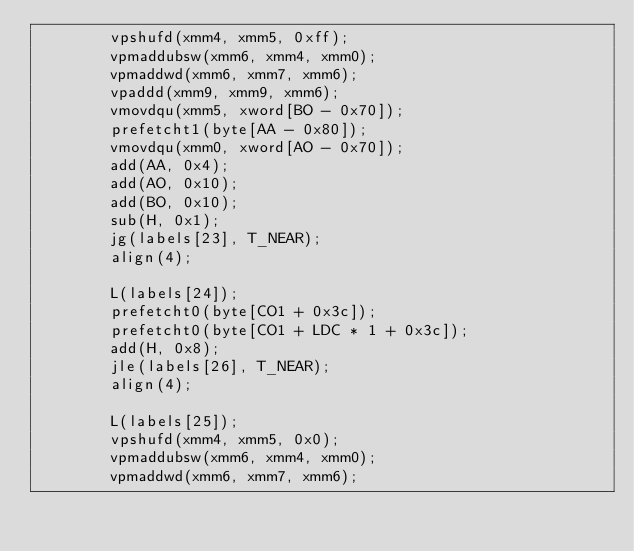Convert code to text. <code><loc_0><loc_0><loc_500><loc_500><_C++_>        vpshufd(xmm4, xmm5, 0xff);
        vpmaddubsw(xmm6, xmm4, xmm0);
        vpmaddwd(xmm6, xmm7, xmm6);
        vpaddd(xmm9, xmm9, xmm6);
        vmovdqu(xmm5, xword[BO - 0x70]);
        prefetcht1(byte[AA - 0x80]);
        vmovdqu(xmm0, xword[AO - 0x70]);
        add(AA, 0x4);
        add(AO, 0x10);
        add(BO, 0x10);
        sub(H, 0x1);
        jg(labels[23], T_NEAR);
        align(4);

        L(labels[24]);
        prefetcht0(byte[CO1 + 0x3c]);
        prefetcht0(byte[CO1 + LDC * 1 + 0x3c]);
        add(H, 0x8);
        jle(labels[26], T_NEAR);
        align(4);

        L(labels[25]);
        vpshufd(xmm4, xmm5, 0x0);
        vpmaddubsw(xmm6, xmm4, xmm0);
        vpmaddwd(xmm6, xmm7, xmm6);</code> 